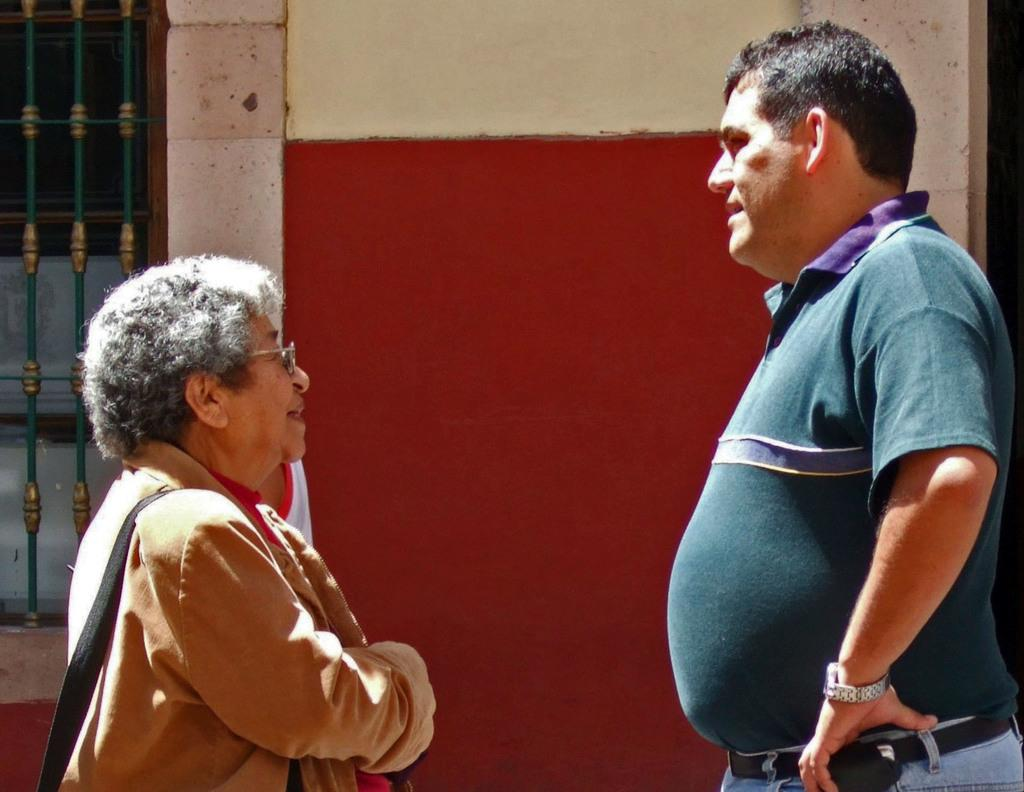Who is present on the right side of the image? There is a man on the right side of the image. Who is present on the left side of the image? There is a lady on the left side of the image. What can be seen behind the lady in the image? There is a window behind the lady. What hobbies does the man have, as depicted in the image? The image does not provide information about the man's hobbies. How does the lady plan to increase her income, as shown in the image? The image does not provide information about the lady's income or plans to increase it. 